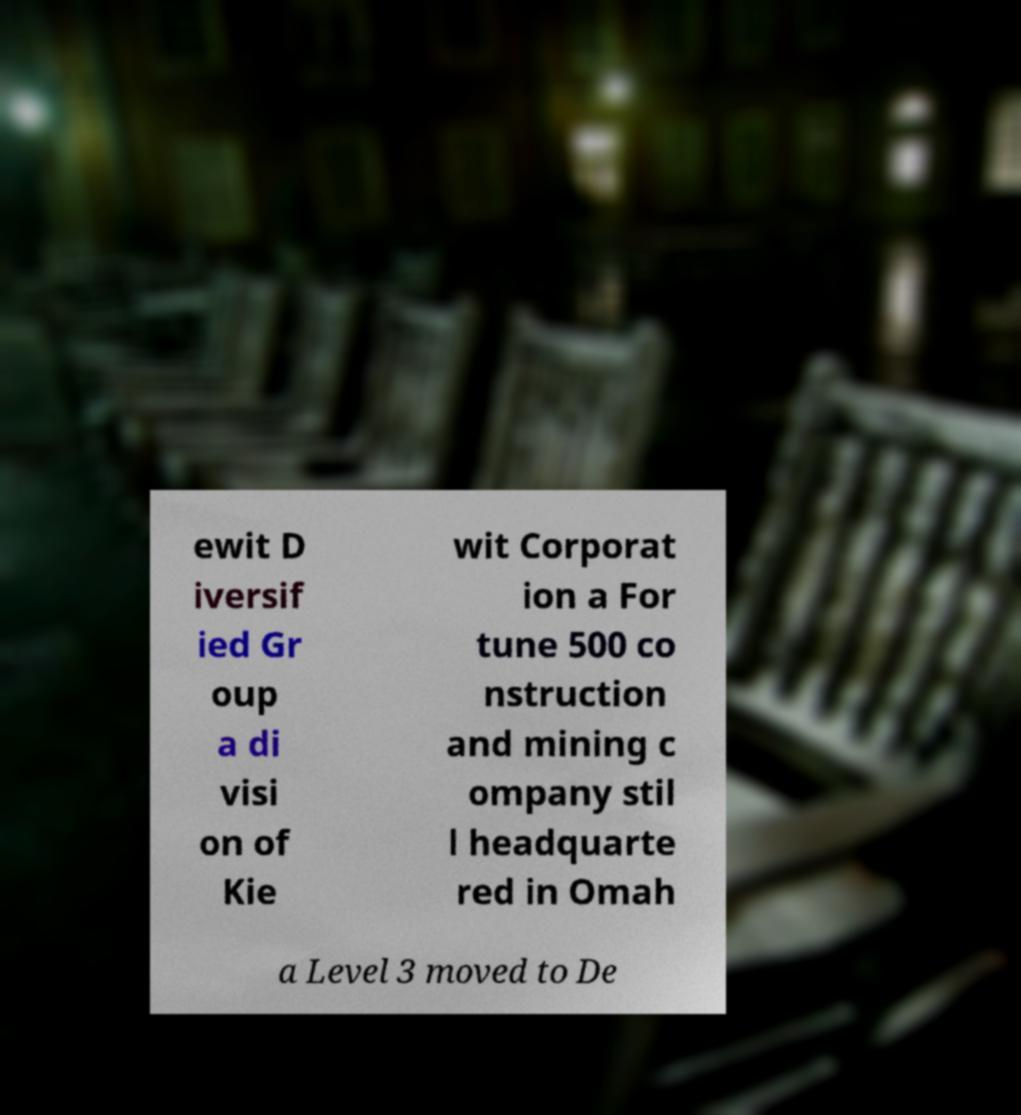Please read and relay the text visible in this image. What does it say? ewit D iversif ied Gr oup a di visi on of Kie wit Corporat ion a For tune 500 co nstruction and mining c ompany stil l headquarte red in Omah a Level 3 moved to De 